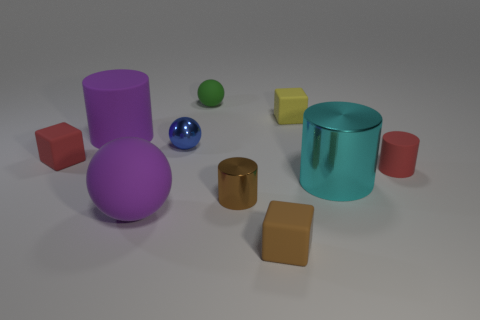Subtract all spheres. How many objects are left? 7 Add 6 tiny blue shiny objects. How many tiny blue shiny objects are left? 7 Add 6 tiny brown matte cubes. How many tiny brown matte cubes exist? 7 Subtract 0 yellow cylinders. How many objects are left? 10 Subtract all small red rubber cylinders. Subtract all green things. How many objects are left? 8 